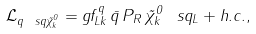Convert formula to latex. <formula><loc_0><loc_0><loc_500><loc_500>\mathcal { L } _ { q \ s q \tilde { \chi } ^ { 0 } _ { k } } = g f ^ { q } _ { L k } \, \bar { q } \, P _ { R } \, \tilde { \chi } ^ { 0 } _ { k } \, \ s q _ { L } + h . c . ,</formula> 